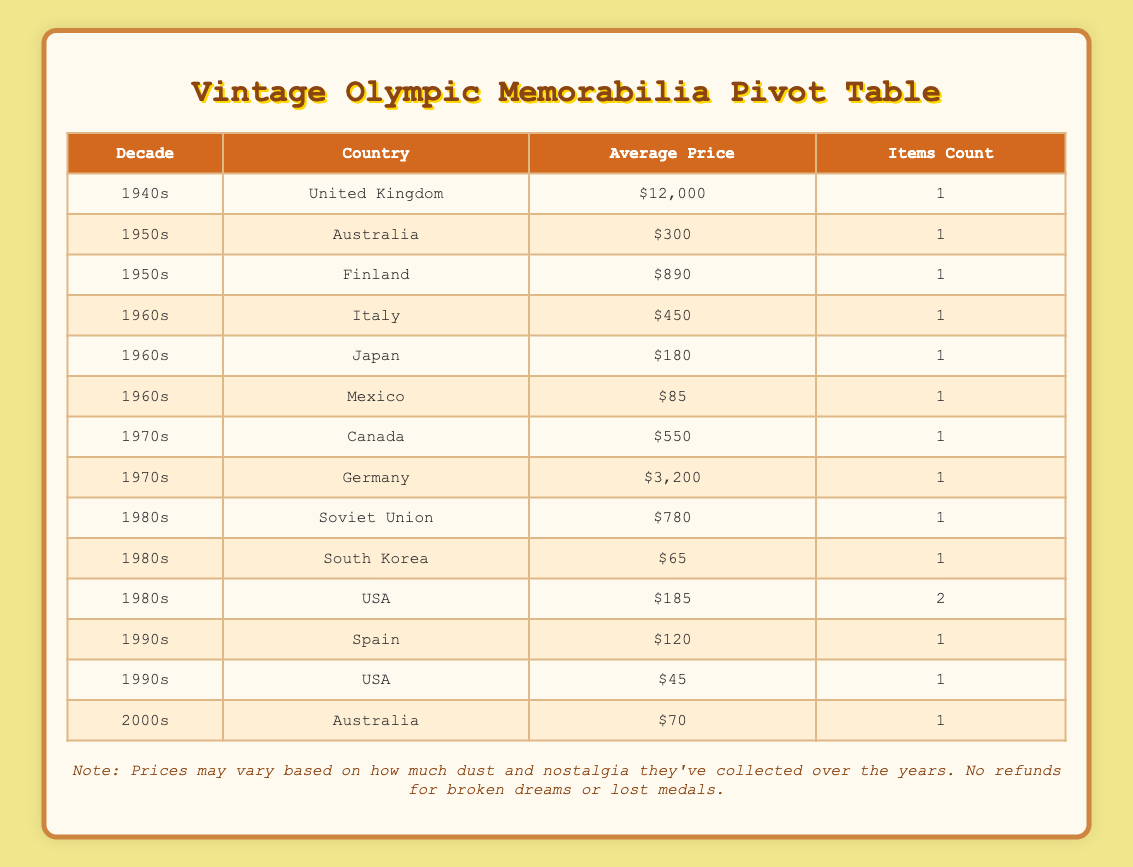What is the average price of memorabilia from the 1960s? To find the average price from the 1960s, we identify the items listed: Rome Olympics Poster ($450), Tokyo Olympics Photo Album ($180), and Mexico City Olympics Ticket Stub ($85). We sum these prices: 450 + 180 + 85 = 715. There are 3 items, so the average is 715 divided by 3, which equals approximately 238.33.
Answer: 238.33 How many items from the USA are represented in the table? The table lists two items from the USA: Los Angeles Olympics Jacket and Lake Placid Winter Olympics Bobsled Pin. Counting these yields a total of 2 items from the USA.
Answer: 2 Which country has the most expensive item listed, and what is the price? The item with the highest price is the London Olympics Torch from the United Kingdom at $12,000. This is determined by checking all listed prices and finding that none are higher than this.
Answer: United Kingdom, $12,000 In which decade did the most expensive item originate? The London Olympics Torch is the most expensive item, and it was from the 1940s. Comparing all decades, we see this item holds the highest price across all items listed in the table.
Answer: 1940s Is there any memorabilia from the 1980s with a price above $700? The Soviet Union's Moscow Olympics Medal is priced at $780, which is above $700. Checking against other items from the 1980s (South Korea's Plush at $65 and USA's Bobsled Pin at $95), confirms that only the Soviet Union medal exceeds $700.
Answer: Yes What is the average price of memorabilia from the 1970s? For the 1970s, there are two items: the Montreal Olympics Participation Medal ($550) and the Munich Olympics Torch ($3,200). The total price is 550 + 3200 = 3750, with 2 items giving an average of 3750 divided by 2, which equals 1875.
Answer: 1875 Is the average price of memorabilia from the 1950s higher than that from the 1980s? The average price for the 1950s can be calculated using the two items: Australian Melbourne Olympics Program ($300) and Finnish Helsinki Olympics Participant Badge ($890), giving 300 + 890 = 1190, averaging to 1190 divided by 2 = 595. From the 1980s, the average price is (780 + 65 + 185) divided by 3 = 343.33. Since 595 is greater than 343.33, the statement is true.
Answer: Yes What decade has the highest average price per item? To find this, we calculate the average prices for each decade. From the 1940s: $12,000, 1950s: $595, 1960s: $238.33, 1970s: $1875, 1980s: $343.33, and 1990s: $82.50. The highest value is for the 1940s at $12,000 based on the calculations done for each decade.
Answer: 1940s How many items from the 2000s are there? There is 1 item from the 2000s listed, which is the Sydney Olympics Boomerang priced at $70. This is determined by reviewing the overview for this specific decade in the table.
Answer: 1 